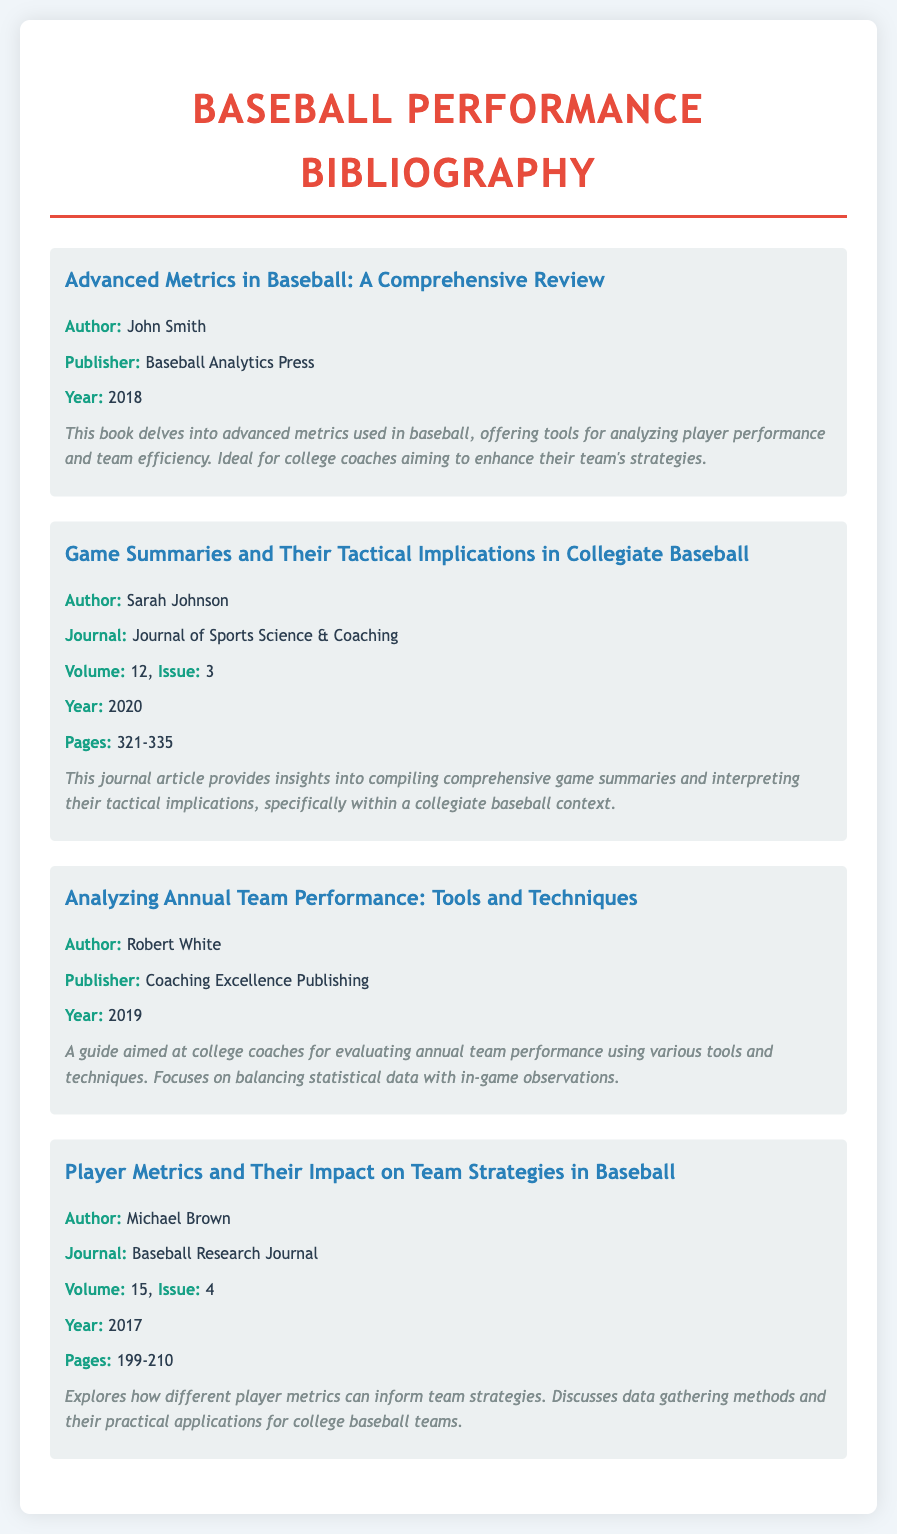What is the title of the first entry? The title of the first entry is the main heading in the document, which is "Advanced Metrics in Baseball: A Comprehensive Review".
Answer: Advanced Metrics in Baseball: A Comprehensive Review Who is the author of the article published in 2020? The author of the article published in 2020 is the name associated with that specific entry in the document, which is "Sarah Johnson".
Answer: Sarah Johnson What year was "Player Metrics and Their Impact on Team Strategies in Baseball" published? The publication year is given in the document and corresponds to the entry in question, which is "2017".
Answer: 2017 Which publisher released "Analyzing Annual Team Performance: Tools and Techniques"? The publisher is specified in the entry about the book, which is "Coaching Excellence Publishing".
Answer: Coaching Excellence Publishing What volume and issue is the article by Michael Brown in? The volume and issue numbers are found in the specific journal's entry in the document, which is "Volume: 15, Issue: 4".
Answer: Volume: 15, Issue: 4 What type of publication is "Game Summaries and Their Tactical Implications in Collegiate Baseball"? The entry indicates the type of publication, which is listed as a "Journal".
Answer: Journal What is the focus of the book by John Smith? The focus of the book is contained in the description and relates to advanced metrics in baseball, specifically for coaches.
Answer: Advanced metrics used in baseball How many pages does Sarah Johnson's article cover? The exact number of pages is provided in the entry of the journal article, which is "321-335".
Answer: 321-335 